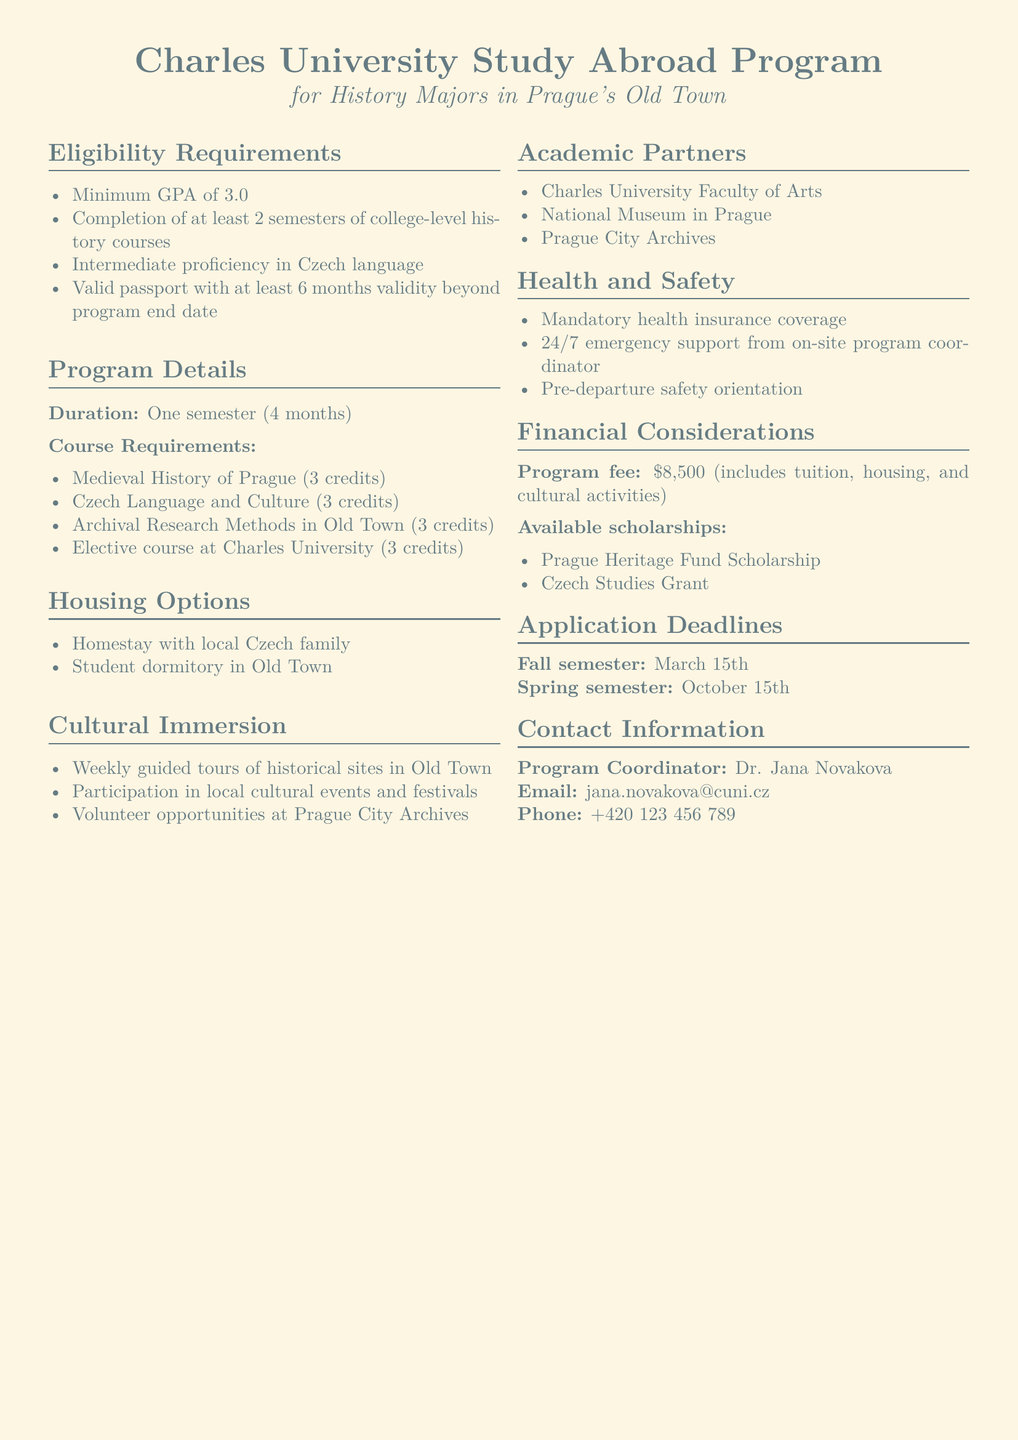What is the minimum GPA requirement? The minimum GPA requirement is mentioned in the eligibility requirements section of the document.
Answer: 3.0 How long is the duration of the program? The duration of the program is specified in the program details section.
Answer: One semester (4 months) Name one of the available scholarships. The available scholarships are listed in the financial considerations section, where multiple options are provided.
Answer: Prague Heritage Fund Scholarship What language proficiency is required? The language proficiency requirement is included in the eligibility section of the document.
Answer: Intermediate proficiency in Czech language Who is the program coordinator? The contact information section includes details about the program coordinator.
Answer: Dr. Jana Novakova How many credits is the course on Medieval History of Prague worth? The course credit is specified in the course requirements section.
Answer: 3 credits What type of housing options are available? The document outlines the housing options available in the housing options section.
Answer: Homestay with local Czech family What is the program fee? The program fee is clearly stated in the financial considerations section of the document.
Answer: $8,500 When is the application deadline for the Fall semester? The application deadlines are provided in the application deadlines section, detailing both semesters.
Answer: March 15th 